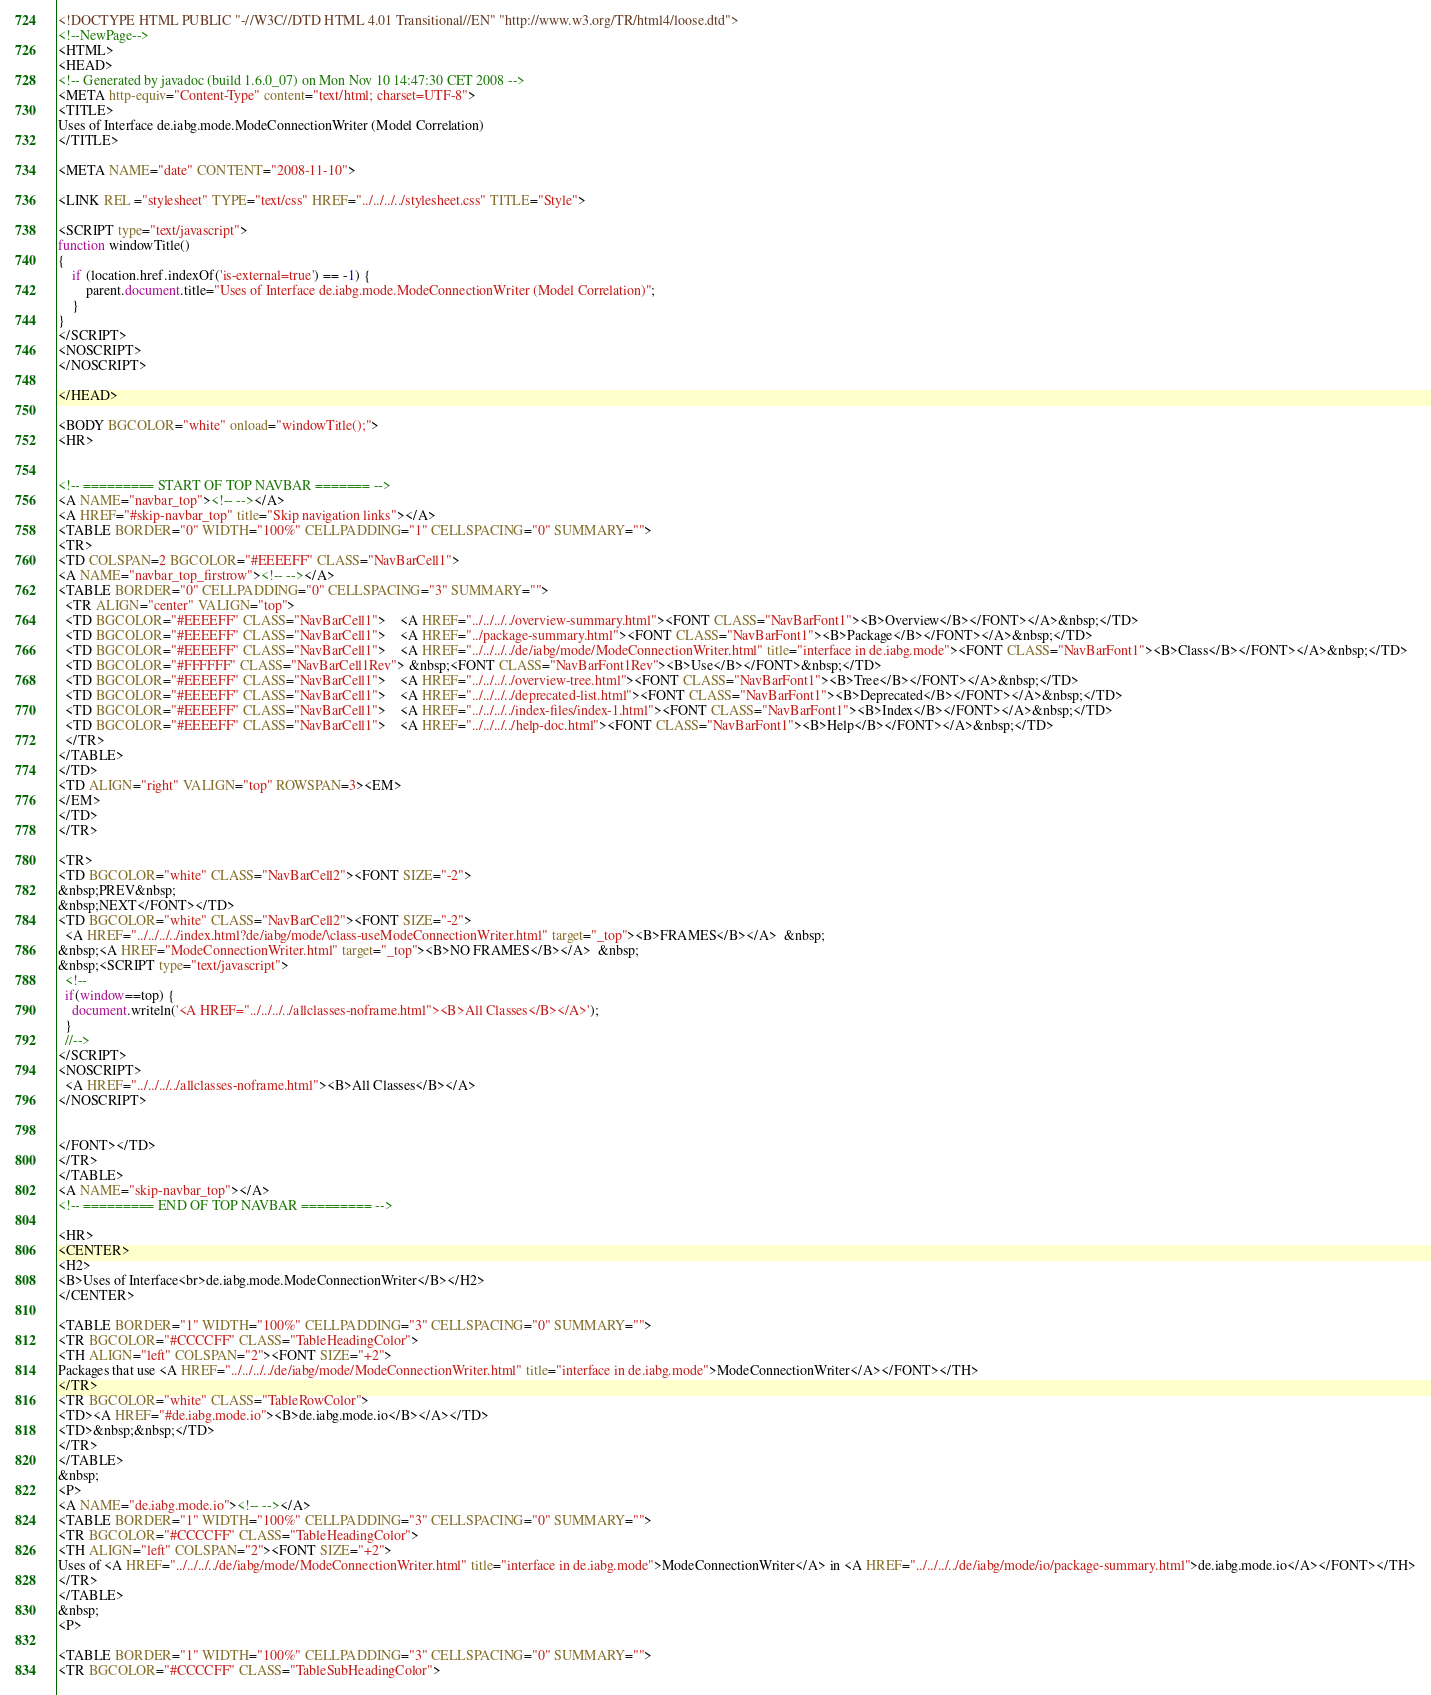Convert code to text. <code><loc_0><loc_0><loc_500><loc_500><_HTML_><!DOCTYPE HTML PUBLIC "-//W3C//DTD HTML 4.01 Transitional//EN" "http://www.w3.org/TR/html4/loose.dtd">
<!--NewPage-->
<HTML>
<HEAD>
<!-- Generated by javadoc (build 1.6.0_07) on Mon Nov 10 14:47:30 CET 2008 -->
<META http-equiv="Content-Type" content="text/html; charset=UTF-8">
<TITLE>
Uses of Interface de.iabg.mode.ModeConnectionWriter (Model Correlation)
</TITLE>

<META NAME="date" CONTENT="2008-11-10">

<LINK REL ="stylesheet" TYPE="text/css" HREF="../../../../stylesheet.css" TITLE="Style">

<SCRIPT type="text/javascript">
function windowTitle()
{
    if (location.href.indexOf('is-external=true') == -1) {
        parent.document.title="Uses of Interface de.iabg.mode.ModeConnectionWriter (Model Correlation)";
    }
}
</SCRIPT>
<NOSCRIPT>
</NOSCRIPT>

</HEAD>

<BODY BGCOLOR="white" onload="windowTitle();">
<HR>


<!-- ========= START OF TOP NAVBAR ======= -->
<A NAME="navbar_top"><!-- --></A>
<A HREF="#skip-navbar_top" title="Skip navigation links"></A>
<TABLE BORDER="0" WIDTH="100%" CELLPADDING="1" CELLSPACING="0" SUMMARY="">
<TR>
<TD COLSPAN=2 BGCOLOR="#EEEEFF" CLASS="NavBarCell1">
<A NAME="navbar_top_firstrow"><!-- --></A>
<TABLE BORDER="0" CELLPADDING="0" CELLSPACING="3" SUMMARY="">
  <TR ALIGN="center" VALIGN="top">
  <TD BGCOLOR="#EEEEFF" CLASS="NavBarCell1">    <A HREF="../../../../overview-summary.html"><FONT CLASS="NavBarFont1"><B>Overview</B></FONT></A>&nbsp;</TD>
  <TD BGCOLOR="#EEEEFF" CLASS="NavBarCell1">    <A HREF="../package-summary.html"><FONT CLASS="NavBarFont1"><B>Package</B></FONT></A>&nbsp;</TD>
  <TD BGCOLOR="#EEEEFF" CLASS="NavBarCell1">    <A HREF="../../../../de/iabg/mode/ModeConnectionWriter.html" title="interface in de.iabg.mode"><FONT CLASS="NavBarFont1"><B>Class</B></FONT></A>&nbsp;</TD>
  <TD BGCOLOR="#FFFFFF" CLASS="NavBarCell1Rev"> &nbsp;<FONT CLASS="NavBarFont1Rev"><B>Use</B></FONT>&nbsp;</TD>
  <TD BGCOLOR="#EEEEFF" CLASS="NavBarCell1">    <A HREF="../../../../overview-tree.html"><FONT CLASS="NavBarFont1"><B>Tree</B></FONT></A>&nbsp;</TD>
  <TD BGCOLOR="#EEEEFF" CLASS="NavBarCell1">    <A HREF="../../../../deprecated-list.html"><FONT CLASS="NavBarFont1"><B>Deprecated</B></FONT></A>&nbsp;</TD>
  <TD BGCOLOR="#EEEEFF" CLASS="NavBarCell1">    <A HREF="../../../../index-files/index-1.html"><FONT CLASS="NavBarFont1"><B>Index</B></FONT></A>&nbsp;</TD>
  <TD BGCOLOR="#EEEEFF" CLASS="NavBarCell1">    <A HREF="../../../../help-doc.html"><FONT CLASS="NavBarFont1"><B>Help</B></FONT></A>&nbsp;</TD>
  </TR>
</TABLE>
</TD>
<TD ALIGN="right" VALIGN="top" ROWSPAN=3><EM>
</EM>
</TD>
</TR>

<TR>
<TD BGCOLOR="white" CLASS="NavBarCell2"><FONT SIZE="-2">
&nbsp;PREV&nbsp;
&nbsp;NEXT</FONT></TD>
<TD BGCOLOR="white" CLASS="NavBarCell2"><FONT SIZE="-2">
  <A HREF="../../../../index.html?de/iabg/mode/\class-useModeConnectionWriter.html" target="_top"><B>FRAMES</B></A>  &nbsp;
&nbsp;<A HREF="ModeConnectionWriter.html" target="_top"><B>NO FRAMES</B></A>  &nbsp;
&nbsp;<SCRIPT type="text/javascript">
  <!--
  if(window==top) {
    document.writeln('<A HREF="../../../../allclasses-noframe.html"><B>All Classes</B></A>');
  }
  //-->
</SCRIPT>
<NOSCRIPT>
  <A HREF="../../../../allclasses-noframe.html"><B>All Classes</B></A>
</NOSCRIPT>


</FONT></TD>
</TR>
</TABLE>
<A NAME="skip-navbar_top"></A>
<!-- ========= END OF TOP NAVBAR ========= -->

<HR>
<CENTER>
<H2>
<B>Uses of Interface<br>de.iabg.mode.ModeConnectionWriter</B></H2>
</CENTER>

<TABLE BORDER="1" WIDTH="100%" CELLPADDING="3" CELLSPACING="0" SUMMARY="">
<TR BGCOLOR="#CCCCFF" CLASS="TableHeadingColor">
<TH ALIGN="left" COLSPAN="2"><FONT SIZE="+2">
Packages that use <A HREF="../../../../de/iabg/mode/ModeConnectionWriter.html" title="interface in de.iabg.mode">ModeConnectionWriter</A></FONT></TH>
</TR>
<TR BGCOLOR="white" CLASS="TableRowColor">
<TD><A HREF="#de.iabg.mode.io"><B>de.iabg.mode.io</B></A></TD>
<TD>&nbsp;&nbsp;</TD>
</TR>
</TABLE>
&nbsp;
<P>
<A NAME="de.iabg.mode.io"><!-- --></A>
<TABLE BORDER="1" WIDTH="100%" CELLPADDING="3" CELLSPACING="0" SUMMARY="">
<TR BGCOLOR="#CCCCFF" CLASS="TableHeadingColor">
<TH ALIGN="left" COLSPAN="2"><FONT SIZE="+2">
Uses of <A HREF="../../../../de/iabg/mode/ModeConnectionWriter.html" title="interface in de.iabg.mode">ModeConnectionWriter</A> in <A HREF="../../../../de/iabg/mode/io/package-summary.html">de.iabg.mode.io</A></FONT></TH>
</TR>
</TABLE>
&nbsp;
<P>

<TABLE BORDER="1" WIDTH="100%" CELLPADDING="3" CELLSPACING="0" SUMMARY="">
<TR BGCOLOR="#CCCCFF" CLASS="TableSubHeadingColor"></code> 